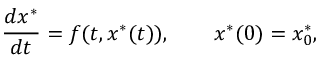<formula> <loc_0><loc_0><loc_500><loc_500>\frac { d x ^ { * } } { d t } = f ( t , x ^ { * } ( t ) ) , \quad x ^ { * } ( 0 ) = x _ { 0 } ^ { * } ,</formula> 